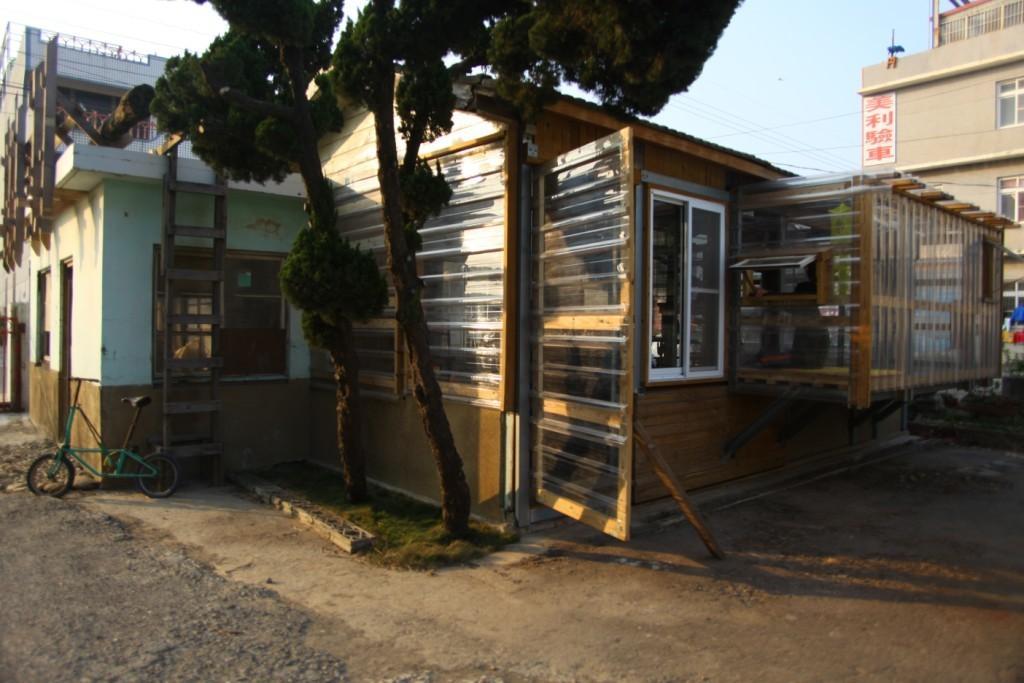Can you describe this image briefly? In this picture we can see a bicycle on the left side. We can see a ladder to the building on the left side. There are a few buildings and trees on the path. 